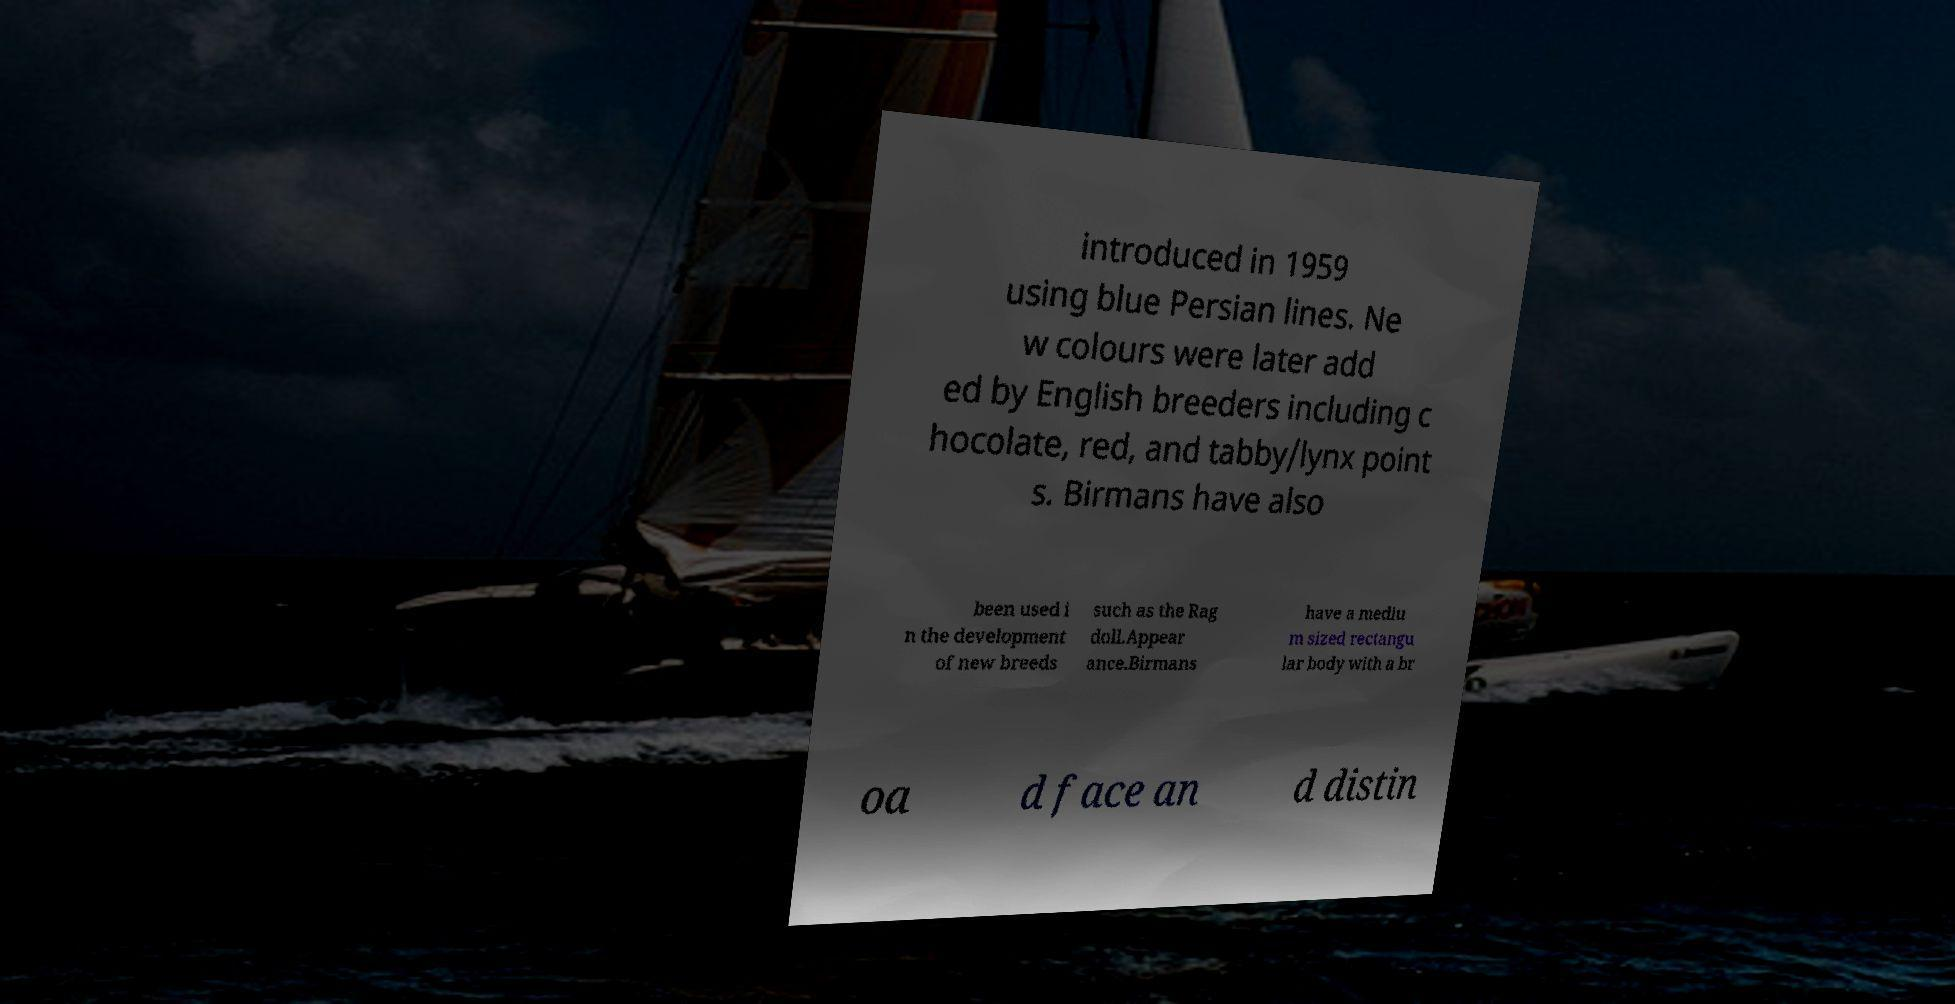Can you read and provide the text displayed in the image?This photo seems to have some interesting text. Can you extract and type it out for me? introduced in 1959 using blue Persian lines. Ne w colours were later add ed by English breeders including c hocolate, red, and tabby/lynx point s. Birmans have also been used i n the development of new breeds such as the Rag doll.Appear ance.Birmans have a mediu m sized rectangu lar body with a br oa d face an d distin 